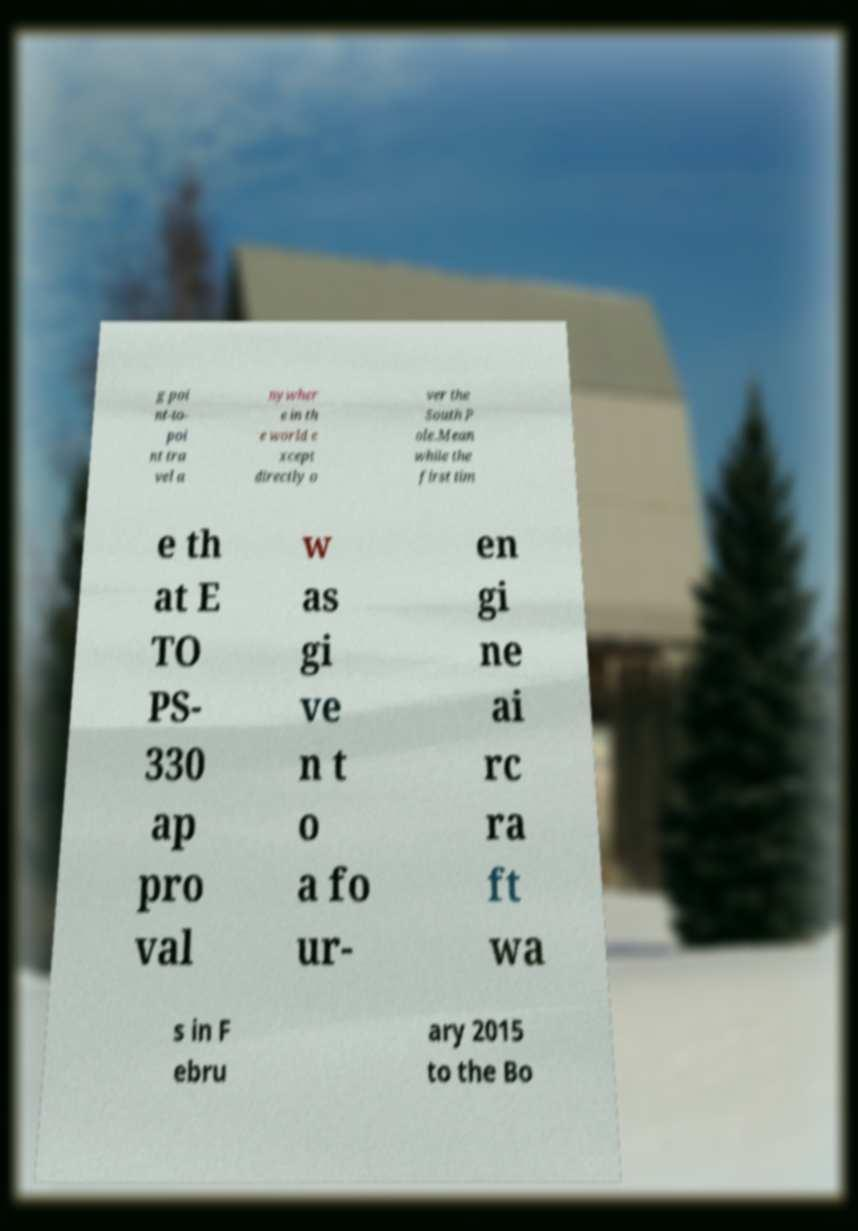Please read and relay the text visible in this image. What does it say? g poi nt-to- poi nt tra vel a nywher e in th e world e xcept directly o ver the South P ole.Mean while the first tim e th at E TO PS- 330 ap pro val w as gi ve n t o a fo ur- en gi ne ai rc ra ft wa s in F ebru ary 2015 to the Bo 